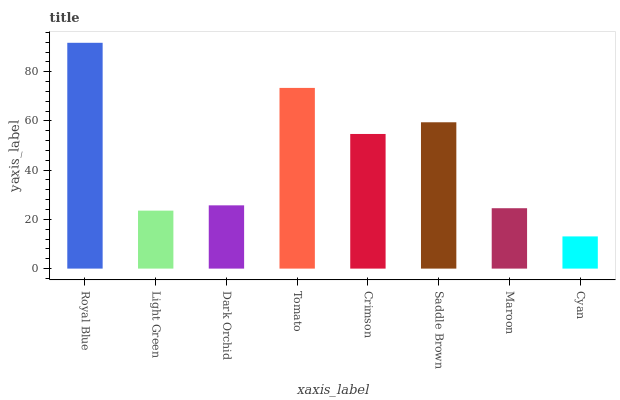Is Light Green the minimum?
Answer yes or no. No. Is Light Green the maximum?
Answer yes or no. No. Is Royal Blue greater than Light Green?
Answer yes or no. Yes. Is Light Green less than Royal Blue?
Answer yes or no. Yes. Is Light Green greater than Royal Blue?
Answer yes or no. No. Is Royal Blue less than Light Green?
Answer yes or no. No. Is Crimson the high median?
Answer yes or no. Yes. Is Dark Orchid the low median?
Answer yes or no. Yes. Is Royal Blue the high median?
Answer yes or no. No. Is Saddle Brown the low median?
Answer yes or no. No. 